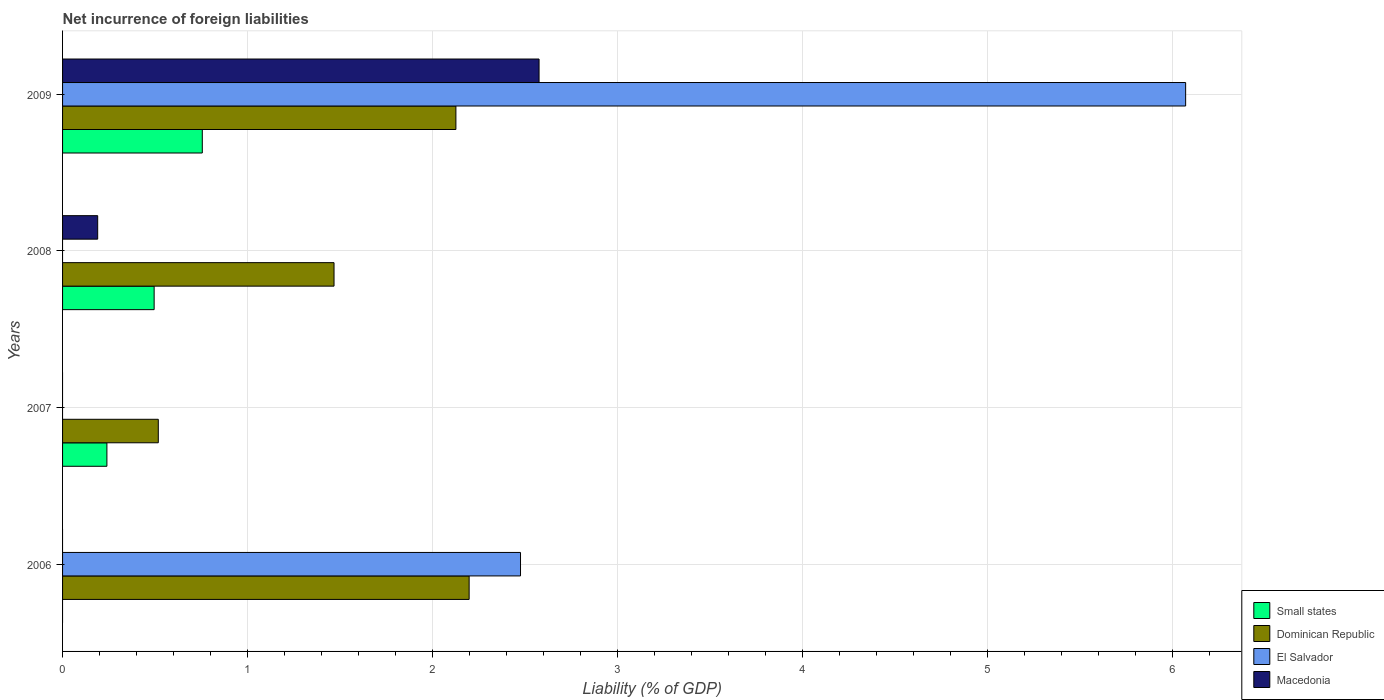How many groups of bars are there?
Your answer should be very brief. 4. Are the number of bars on each tick of the Y-axis equal?
Give a very brief answer. No. How many bars are there on the 4th tick from the bottom?
Your answer should be compact. 4. In how many cases, is the number of bars for a given year not equal to the number of legend labels?
Keep it short and to the point. 3. Across all years, what is the maximum net incurrence of foreign liabilities in El Salvador?
Offer a very short reply. 6.07. In which year was the net incurrence of foreign liabilities in Small states maximum?
Provide a succinct answer. 2009. What is the total net incurrence of foreign liabilities in Small states in the graph?
Offer a terse response. 1.49. What is the difference between the net incurrence of foreign liabilities in Macedonia in 2008 and that in 2009?
Offer a terse response. -2.39. What is the difference between the net incurrence of foreign liabilities in Macedonia in 2009 and the net incurrence of foreign liabilities in Dominican Republic in 2007?
Your answer should be compact. 2.06. What is the average net incurrence of foreign liabilities in Dominican Republic per year?
Provide a succinct answer. 1.58. In the year 2009, what is the difference between the net incurrence of foreign liabilities in Macedonia and net incurrence of foreign liabilities in El Salvador?
Ensure brevity in your answer.  -3.5. In how many years, is the net incurrence of foreign liabilities in Macedonia greater than 5 %?
Provide a succinct answer. 0. What is the ratio of the net incurrence of foreign liabilities in Macedonia in 2008 to that in 2009?
Give a very brief answer. 0.07. Is the net incurrence of foreign liabilities in Dominican Republic in 2006 less than that in 2007?
Your response must be concise. No. What is the difference between the highest and the second highest net incurrence of foreign liabilities in Dominican Republic?
Your answer should be compact. 0.07. What is the difference between the highest and the lowest net incurrence of foreign liabilities in Macedonia?
Offer a terse response. 2.58. Is the sum of the net incurrence of foreign liabilities in Small states in 2007 and 2009 greater than the maximum net incurrence of foreign liabilities in Macedonia across all years?
Keep it short and to the point. No. Are all the bars in the graph horizontal?
Your response must be concise. Yes. How many years are there in the graph?
Offer a very short reply. 4. What is the difference between two consecutive major ticks on the X-axis?
Provide a short and direct response. 1. Where does the legend appear in the graph?
Offer a terse response. Bottom right. How many legend labels are there?
Your answer should be compact. 4. How are the legend labels stacked?
Provide a succinct answer. Vertical. What is the title of the graph?
Your response must be concise. Net incurrence of foreign liabilities. What is the label or title of the X-axis?
Your answer should be very brief. Liability (% of GDP). What is the Liability (% of GDP) of Dominican Republic in 2006?
Keep it short and to the point. 2.2. What is the Liability (% of GDP) in El Salvador in 2006?
Your response must be concise. 2.48. What is the Liability (% of GDP) in Macedonia in 2006?
Give a very brief answer. 0. What is the Liability (% of GDP) in Small states in 2007?
Your answer should be compact. 0.24. What is the Liability (% of GDP) in Dominican Republic in 2007?
Your answer should be compact. 0.52. What is the Liability (% of GDP) of Small states in 2008?
Keep it short and to the point. 0.5. What is the Liability (% of GDP) of Dominican Republic in 2008?
Provide a short and direct response. 1.47. What is the Liability (% of GDP) in El Salvador in 2008?
Provide a succinct answer. 0. What is the Liability (% of GDP) in Macedonia in 2008?
Ensure brevity in your answer.  0.19. What is the Liability (% of GDP) of Small states in 2009?
Give a very brief answer. 0.76. What is the Liability (% of GDP) in Dominican Republic in 2009?
Give a very brief answer. 2.13. What is the Liability (% of GDP) in El Salvador in 2009?
Your response must be concise. 6.07. What is the Liability (% of GDP) of Macedonia in 2009?
Give a very brief answer. 2.58. Across all years, what is the maximum Liability (% of GDP) of Small states?
Your answer should be very brief. 0.76. Across all years, what is the maximum Liability (% of GDP) of Dominican Republic?
Your response must be concise. 2.2. Across all years, what is the maximum Liability (% of GDP) of El Salvador?
Your answer should be compact. 6.07. Across all years, what is the maximum Liability (% of GDP) in Macedonia?
Offer a terse response. 2.58. Across all years, what is the minimum Liability (% of GDP) of Small states?
Offer a terse response. 0. Across all years, what is the minimum Liability (% of GDP) of Dominican Republic?
Give a very brief answer. 0.52. What is the total Liability (% of GDP) of Small states in the graph?
Your answer should be compact. 1.49. What is the total Liability (% of GDP) of Dominican Republic in the graph?
Ensure brevity in your answer.  6.31. What is the total Liability (% of GDP) in El Salvador in the graph?
Offer a terse response. 8.55. What is the total Liability (% of GDP) in Macedonia in the graph?
Your answer should be very brief. 2.77. What is the difference between the Liability (% of GDP) in Dominican Republic in 2006 and that in 2007?
Offer a very short reply. 1.68. What is the difference between the Liability (% of GDP) of Dominican Republic in 2006 and that in 2008?
Make the answer very short. 0.73. What is the difference between the Liability (% of GDP) in Dominican Republic in 2006 and that in 2009?
Your answer should be compact. 0.07. What is the difference between the Liability (% of GDP) of El Salvador in 2006 and that in 2009?
Make the answer very short. -3.6. What is the difference between the Liability (% of GDP) in Small states in 2007 and that in 2008?
Keep it short and to the point. -0.26. What is the difference between the Liability (% of GDP) of Dominican Republic in 2007 and that in 2008?
Ensure brevity in your answer.  -0.95. What is the difference between the Liability (% of GDP) of Small states in 2007 and that in 2009?
Your response must be concise. -0.52. What is the difference between the Liability (% of GDP) of Dominican Republic in 2007 and that in 2009?
Provide a succinct answer. -1.61. What is the difference between the Liability (% of GDP) of Small states in 2008 and that in 2009?
Give a very brief answer. -0.26. What is the difference between the Liability (% of GDP) of Dominican Republic in 2008 and that in 2009?
Offer a very short reply. -0.66. What is the difference between the Liability (% of GDP) of Macedonia in 2008 and that in 2009?
Your answer should be compact. -2.39. What is the difference between the Liability (% of GDP) in Dominican Republic in 2006 and the Liability (% of GDP) in Macedonia in 2008?
Keep it short and to the point. 2.01. What is the difference between the Liability (% of GDP) in El Salvador in 2006 and the Liability (% of GDP) in Macedonia in 2008?
Ensure brevity in your answer.  2.29. What is the difference between the Liability (% of GDP) in Dominican Republic in 2006 and the Liability (% of GDP) in El Salvador in 2009?
Make the answer very short. -3.87. What is the difference between the Liability (% of GDP) in Dominican Republic in 2006 and the Liability (% of GDP) in Macedonia in 2009?
Your response must be concise. -0.38. What is the difference between the Liability (% of GDP) of El Salvador in 2006 and the Liability (% of GDP) of Macedonia in 2009?
Your answer should be compact. -0.1. What is the difference between the Liability (% of GDP) of Small states in 2007 and the Liability (% of GDP) of Dominican Republic in 2008?
Give a very brief answer. -1.23. What is the difference between the Liability (% of GDP) in Small states in 2007 and the Liability (% of GDP) in Macedonia in 2008?
Your answer should be compact. 0.05. What is the difference between the Liability (% of GDP) in Dominican Republic in 2007 and the Liability (% of GDP) in Macedonia in 2008?
Give a very brief answer. 0.33. What is the difference between the Liability (% of GDP) of Small states in 2007 and the Liability (% of GDP) of Dominican Republic in 2009?
Make the answer very short. -1.89. What is the difference between the Liability (% of GDP) of Small states in 2007 and the Liability (% of GDP) of El Salvador in 2009?
Make the answer very short. -5.83. What is the difference between the Liability (% of GDP) of Small states in 2007 and the Liability (% of GDP) of Macedonia in 2009?
Ensure brevity in your answer.  -2.34. What is the difference between the Liability (% of GDP) in Dominican Republic in 2007 and the Liability (% of GDP) in El Salvador in 2009?
Offer a very short reply. -5.56. What is the difference between the Liability (% of GDP) in Dominican Republic in 2007 and the Liability (% of GDP) in Macedonia in 2009?
Give a very brief answer. -2.06. What is the difference between the Liability (% of GDP) of Small states in 2008 and the Liability (% of GDP) of Dominican Republic in 2009?
Your response must be concise. -1.63. What is the difference between the Liability (% of GDP) of Small states in 2008 and the Liability (% of GDP) of El Salvador in 2009?
Your response must be concise. -5.58. What is the difference between the Liability (% of GDP) of Small states in 2008 and the Liability (% of GDP) of Macedonia in 2009?
Your answer should be very brief. -2.08. What is the difference between the Liability (% of GDP) of Dominican Republic in 2008 and the Liability (% of GDP) of El Salvador in 2009?
Make the answer very short. -4.61. What is the difference between the Liability (% of GDP) of Dominican Republic in 2008 and the Liability (% of GDP) of Macedonia in 2009?
Keep it short and to the point. -1.11. What is the average Liability (% of GDP) of Small states per year?
Give a very brief answer. 0.37. What is the average Liability (% of GDP) of Dominican Republic per year?
Provide a short and direct response. 1.58. What is the average Liability (% of GDP) in El Salvador per year?
Make the answer very short. 2.14. What is the average Liability (% of GDP) of Macedonia per year?
Make the answer very short. 0.69. In the year 2006, what is the difference between the Liability (% of GDP) of Dominican Republic and Liability (% of GDP) of El Salvador?
Keep it short and to the point. -0.28. In the year 2007, what is the difference between the Liability (% of GDP) in Small states and Liability (% of GDP) in Dominican Republic?
Make the answer very short. -0.28. In the year 2008, what is the difference between the Liability (% of GDP) in Small states and Liability (% of GDP) in Dominican Republic?
Your answer should be compact. -0.97. In the year 2008, what is the difference between the Liability (% of GDP) of Small states and Liability (% of GDP) of Macedonia?
Provide a succinct answer. 0.31. In the year 2008, what is the difference between the Liability (% of GDP) in Dominican Republic and Liability (% of GDP) in Macedonia?
Ensure brevity in your answer.  1.28. In the year 2009, what is the difference between the Liability (% of GDP) of Small states and Liability (% of GDP) of Dominican Republic?
Your response must be concise. -1.37. In the year 2009, what is the difference between the Liability (% of GDP) of Small states and Liability (% of GDP) of El Salvador?
Give a very brief answer. -5.32. In the year 2009, what is the difference between the Liability (% of GDP) in Small states and Liability (% of GDP) in Macedonia?
Your answer should be compact. -1.82. In the year 2009, what is the difference between the Liability (% of GDP) of Dominican Republic and Liability (% of GDP) of El Salvador?
Ensure brevity in your answer.  -3.95. In the year 2009, what is the difference between the Liability (% of GDP) of Dominican Republic and Liability (% of GDP) of Macedonia?
Ensure brevity in your answer.  -0.45. In the year 2009, what is the difference between the Liability (% of GDP) of El Salvador and Liability (% of GDP) of Macedonia?
Offer a very short reply. 3.5. What is the ratio of the Liability (% of GDP) in Dominican Republic in 2006 to that in 2007?
Provide a succinct answer. 4.25. What is the ratio of the Liability (% of GDP) of Dominican Republic in 2006 to that in 2008?
Your response must be concise. 1.5. What is the ratio of the Liability (% of GDP) of Dominican Republic in 2006 to that in 2009?
Offer a terse response. 1.03. What is the ratio of the Liability (% of GDP) of El Salvador in 2006 to that in 2009?
Provide a succinct answer. 0.41. What is the ratio of the Liability (% of GDP) of Small states in 2007 to that in 2008?
Provide a succinct answer. 0.48. What is the ratio of the Liability (% of GDP) of Dominican Republic in 2007 to that in 2008?
Provide a succinct answer. 0.35. What is the ratio of the Liability (% of GDP) in Small states in 2007 to that in 2009?
Give a very brief answer. 0.32. What is the ratio of the Liability (% of GDP) of Dominican Republic in 2007 to that in 2009?
Keep it short and to the point. 0.24. What is the ratio of the Liability (% of GDP) in Small states in 2008 to that in 2009?
Your answer should be compact. 0.66. What is the ratio of the Liability (% of GDP) in Dominican Republic in 2008 to that in 2009?
Keep it short and to the point. 0.69. What is the ratio of the Liability (% of GDP) of Macedonia in 2008 to that in 2009?
Your answer should be compact. 0.07. What is the difference between the highest and the second highest Liability (% of GDP) in Small states?
Give a very brief answer. 0.26. What is the difference between the highest and the second highest Liability (% of GDP) of Dominican Republic?
Your answer should be very brief. 0.07. What is the difference between the highest and the lowest Liability (% of GDP) of Small states?
Offer a terse response. 0.76. What is the difference between the highest and the lowest Liability (% of GDP) of Dominican Republic?
Make the answer very short. 1.68. What is the difference between the highest and the lowest Liability (% of GDP) of El Salvador?
Give a very brief answer. 6.07. What is the difference between the highest and the lowest Liability (% of GDP) of Macedonia?
Offer a very short reply. 2.58. 